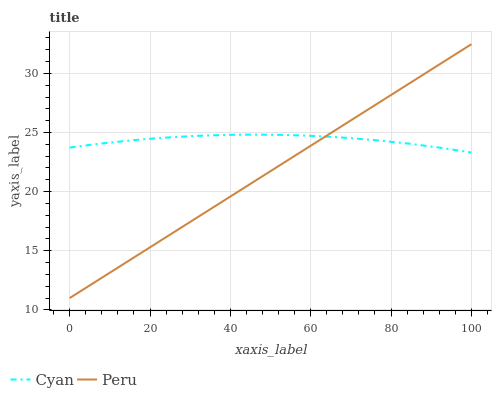Does Peru have the maximum area under the curve?
Answer yes or no. No. Is Peru the roughest?
Answer yes or no. No. 